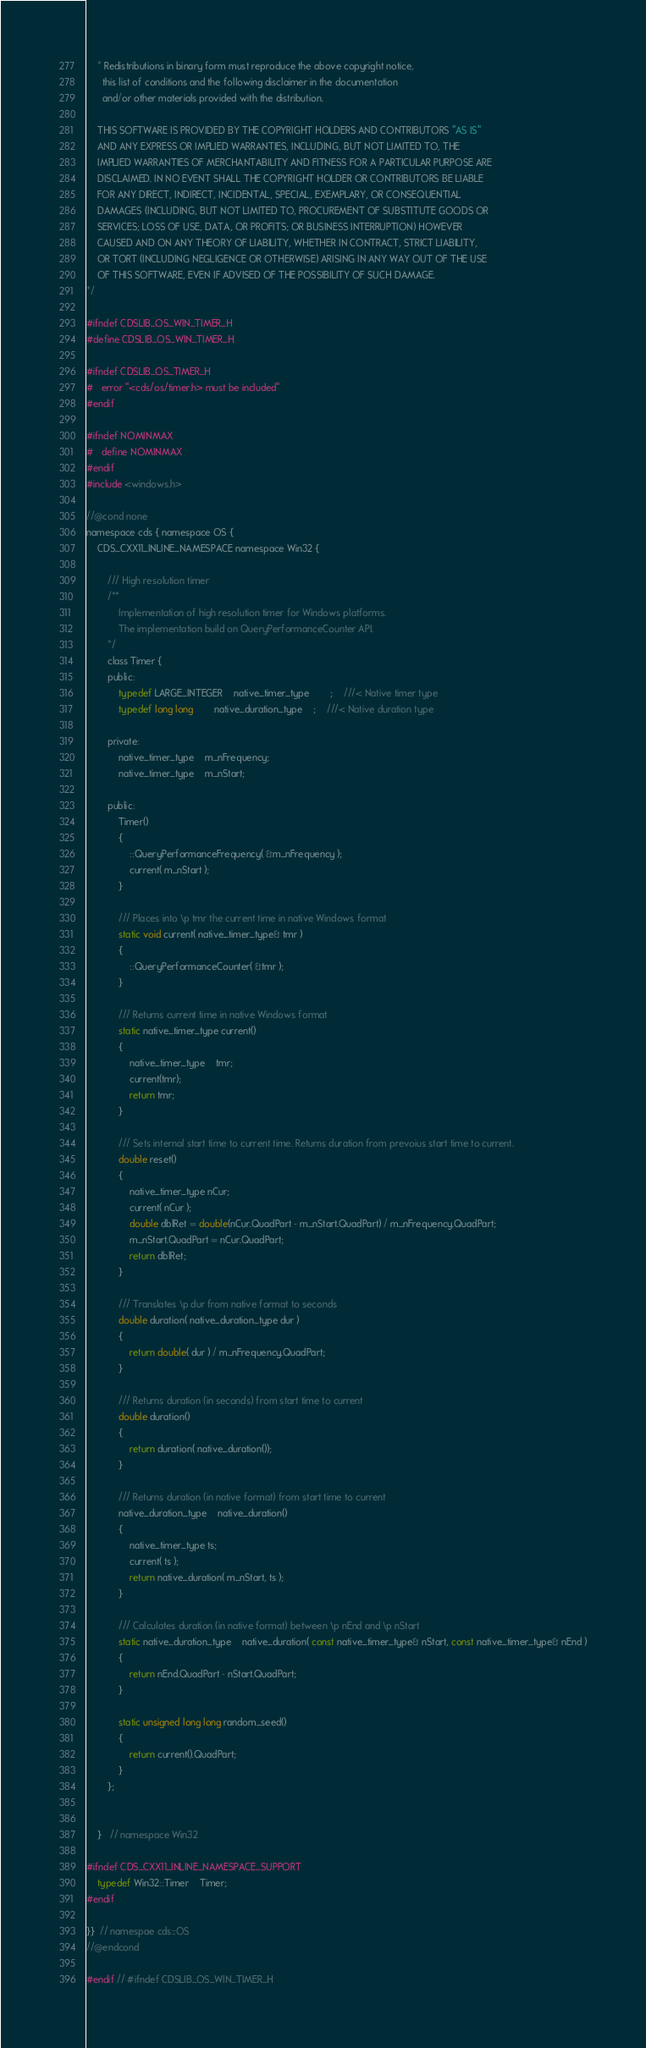Convert code to text. <code><loc_0><loc_0><loc_500><loc_500><_C_>    * Redistributions in binary form must reproduce the above copyright notice,
      this list of conditions and the following disclaimer in the documentation
      and/or other materials provided with the distribution.

    THIS SOFTWARE IS PROVIDED BY THE COPYRIGHT HOLDERS AND CONTRIBUTORS "AS IS"
    AND ANY EXPRESS OR IMPLIED WARRANTIES, INCLUDING, BUT NOT LIMITED TO, THE
    IMPLIED WARRANTIES OF MERCHANTABILITY AND FITNESS FOR A PARTICULAR PURPOSE ARE
    DISCLAIMED. IN NO EVENT SHALL THE COPYRIGHT HOLDER OR CONTRIBUTORS BE LIABLE
    FOR ANY DIRECT, INDIRECT, INCIDENTAL, SPECIAL, EXEMPLARY, OR CONSEQUENTIAL
    DAMAGES (INCLUDING, BUT NOT LIMITED TO, PROCUREMENT OF SUBSTITUTE GOODS OR
    SERVICES; LOSS OF USE, DATA, OR PROFITS; OR BUSINESS INTERRUPTION) HOWEVER
    CAUSED AND ON ANY THEORY OF LIABILITY, WHETHER IN CONTRACT, STRICT LIABILITY,
    OR TORT (INCLUDING NEGLIGENCE OR OTHERWISE) ARISING IN ANY WAY OUT OF THE USE
    OF THIS SOFTWARE, EVEN IF ADVISED OF THE POSSIBILITY OF SUCH DAMAGE.
*/

#ifndef CDSLIB_OS_WIN_TIMER_H
#define CDSLIB_OS_WIN_TIMER_H

#ifndef CDSLIB_OS_TIMER_H
#   error "<cds/os/timer.h> must be included"
#endif

#ifndef NOMINMAX
#   define NOMINMAX
#endif
#include <windows.h>

//@cond none
namespace cds { namespace OS {
    CDS_CXX11_INLINE_NAMESPACE namespace Win32 {

        /// High resolution timer
        /**
            Implementation of high resolution timer for Windows platforms.
            The implementation build on QueryPerformanceCounter API.
        */
        class Timer {
        public:
            typedef LARGE_INTEGER    native_timer_type        ;    ///< Native timer type
            typedef long long        native_duration_type    ;    ///< Native duration type

        private:
            native_timer_type    m_nFrequency;
            native_timer_type    m_nStart;

        public:
            Timer()
            {
                ::QueryPerformanceFrequency( &m_nFrequency );
                current( m_nStart );
            }

            /// Places into \p tmr the current time in native Windows format
            static void current( native_timer_type& tmr )
            {
                ::QueryPerformanceCounter( &tmr );
            }

            /// Returns current time in native Windows format
            static native_timer_type current()
            {
                native_timer_type    tmr;
                current(tmr);
                return tmr;
            }

            /// Sets internal start time to current time. Returns duration from prevoius start time to current.
            double reset()
            {
                native_timer_type nCur;
                current( nCur );
                double dblRet = double(nCur.QuadPart - m_nStart.QuadPart) / m_nFrequency.QuadPart;
                m_nStart.QuadPart = nCur.QuadPart;
                return dblRet;
            }

            /// Translates \p dur from native format to seconds
            double duration( native_duration_type dur )
            {
                return double( dur ) / m_nFrequency.QuadPart;
            }

            /// Returns duration (in seconds) from start time to current
            double duration()
            {
                return duration( native_duration());
            }

            /// Returns duration (in native format) from start time to current
            native_duration_type    native_duration()
            {
                native_timer_type ts;
                current( ts );
                return native_duration( m_nStart, ts );
            }

            /// Calculates duration (in native format) between \p nEnd and \p nStart
            static native_duration_type    native_duration( const native_timer_type& nStart, const native_timer_type& nEnd )
            {
                return nEnd.QuadPart - nStart.QuadPart;
            }

            static unsigned long long random_seed()
            {
                return current().QuadPart;
            }
        };


    }   // namespace Win32

#ifndef CDS_CXX11_INLINE_NAMESPACE_SUPPORT
    typedef Win32::Timer    Timer;
#endif

}}  // namespae cds::OS
//@endcond

#endif // #ifndef CDSLIB_OS_WIN_TIMER_H
</code> 